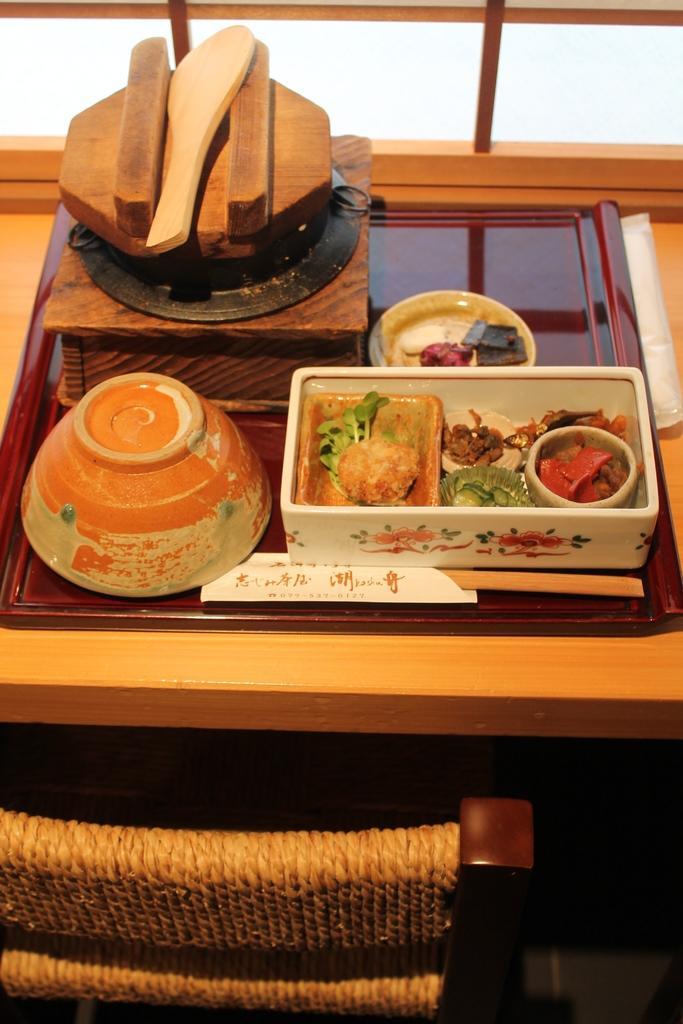Can you describe this image briefly? Here in this picture w can see a table, on which we can see box of food, a bowl, a spoon and a box, all present on it over there and we can also see a chair present on the floor over there. 